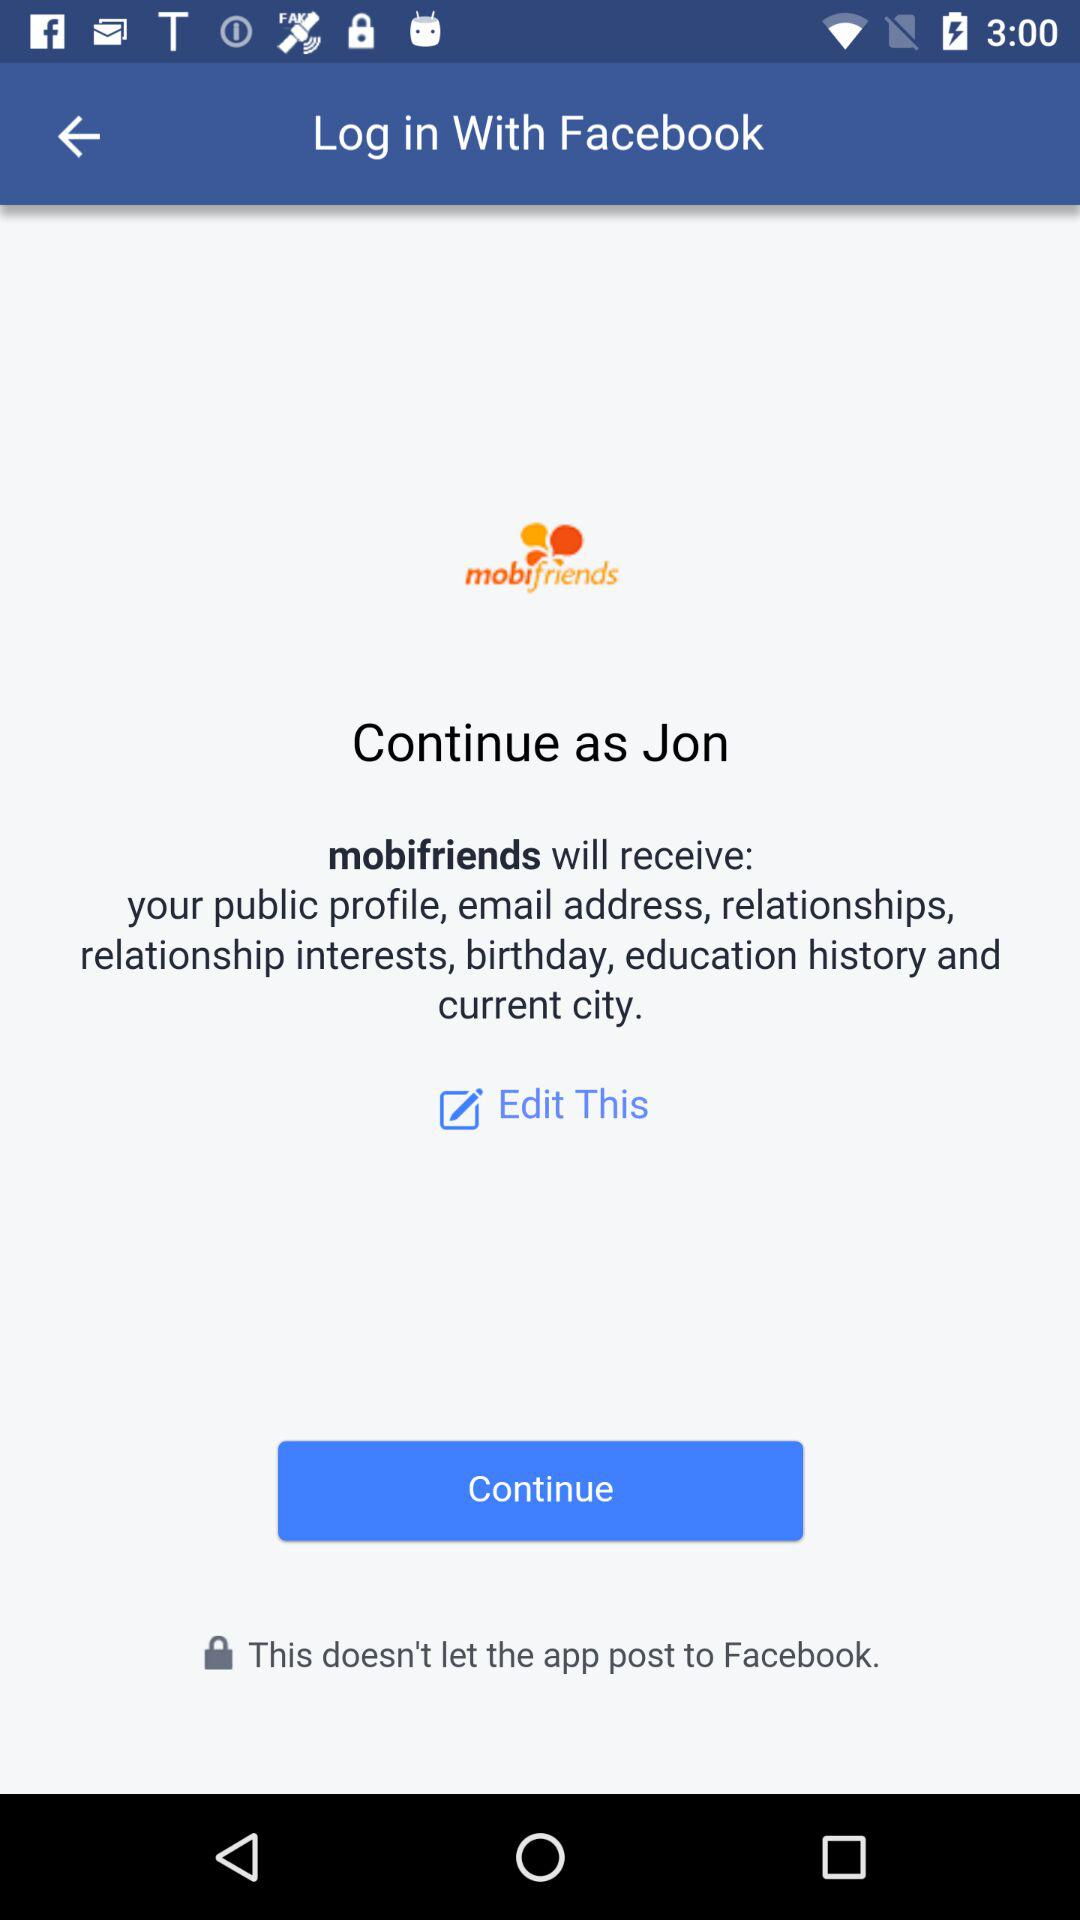Which information will "mobifriends" receive? The application "mobifriends" will receive the public profile, email address, relationships, relationship interests, birthday, education history and current city. 